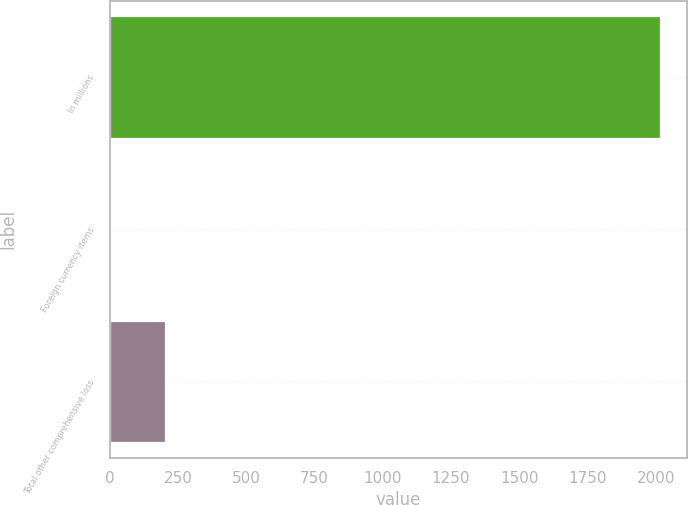Convert chart to OTSL. <chart><loc_0><loc_0><loc_500><loc_500><bar_chart><fcel>In millions<fcel>Foreign currency items<fcel>Total other comprehensive loss<nl><fcel>2015<fcel>1.4<fcel>202.76<nl></chart> 